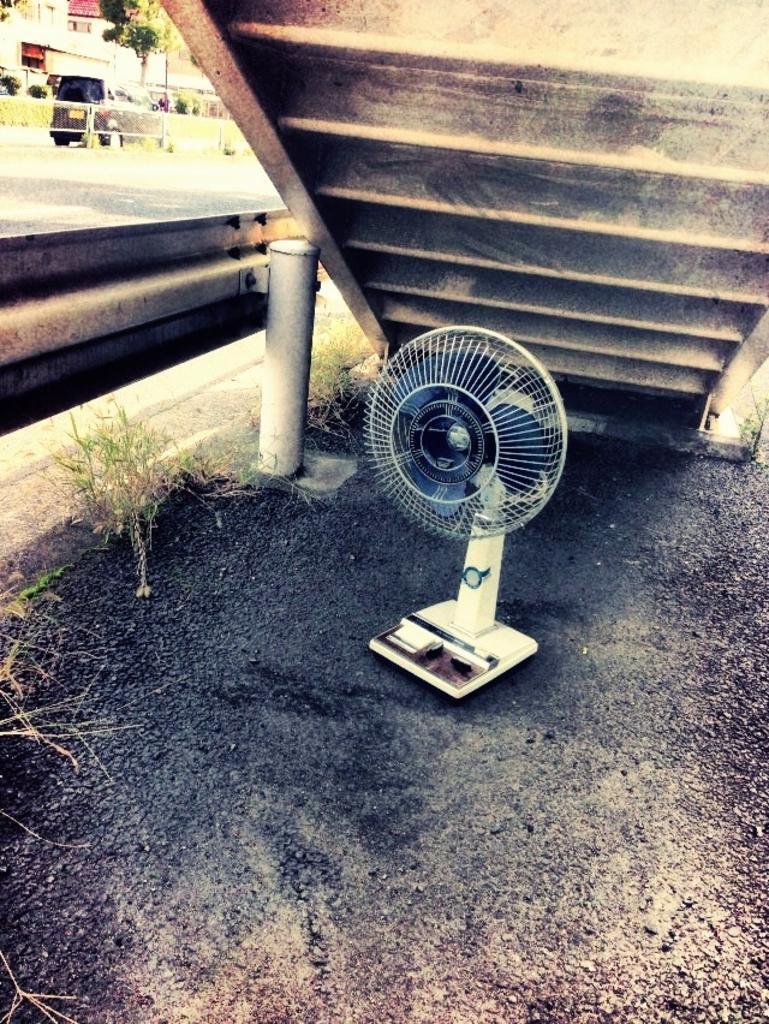Could you give a brief overview of what you see in this image? We can see fan on the surface, above the fan we can see steps. We can see grass, pole and road. In the background we can see vehicle, fence, tree, plants and wall. 